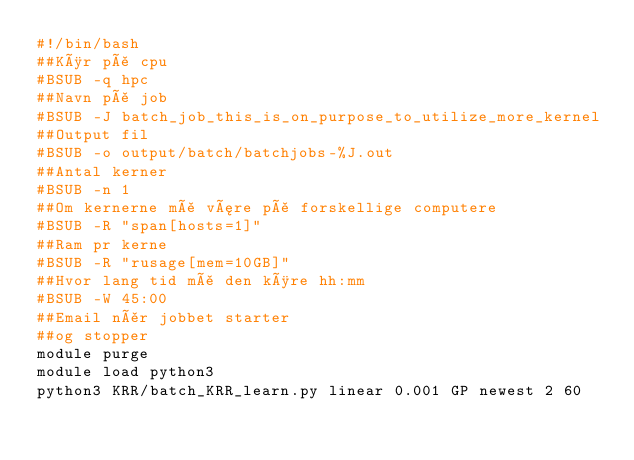Convert code to text. <code><loc_0><loc_0><loc_500><loc_500><_Bash_>#!/bin/bash
##Kør på cpu
#BSUB -q hpc
##Navn på job
#BSUB -J batch_job_this_is_on_purpose_to_utilize_more_kernel
##Output fil
#BSUB -o output/batch/batchjobs-%J.out
##Antal kerner
#BSUB -n 1
##Om kernerne må være på forskellige computere
#BSUB -R "span[hosts=1]"
##Ram pr kerne
#BSUB -R "rusage[mem=10GB]"
##Hvor lang tid må den køre hh:mm
#BSUB -W 45:00
##Email når jobbet starter
##og stopper
module purge
module load python3
python3 KRR/batch_KRR_learn.py linear 0.001 GP newest 2 60</code> 